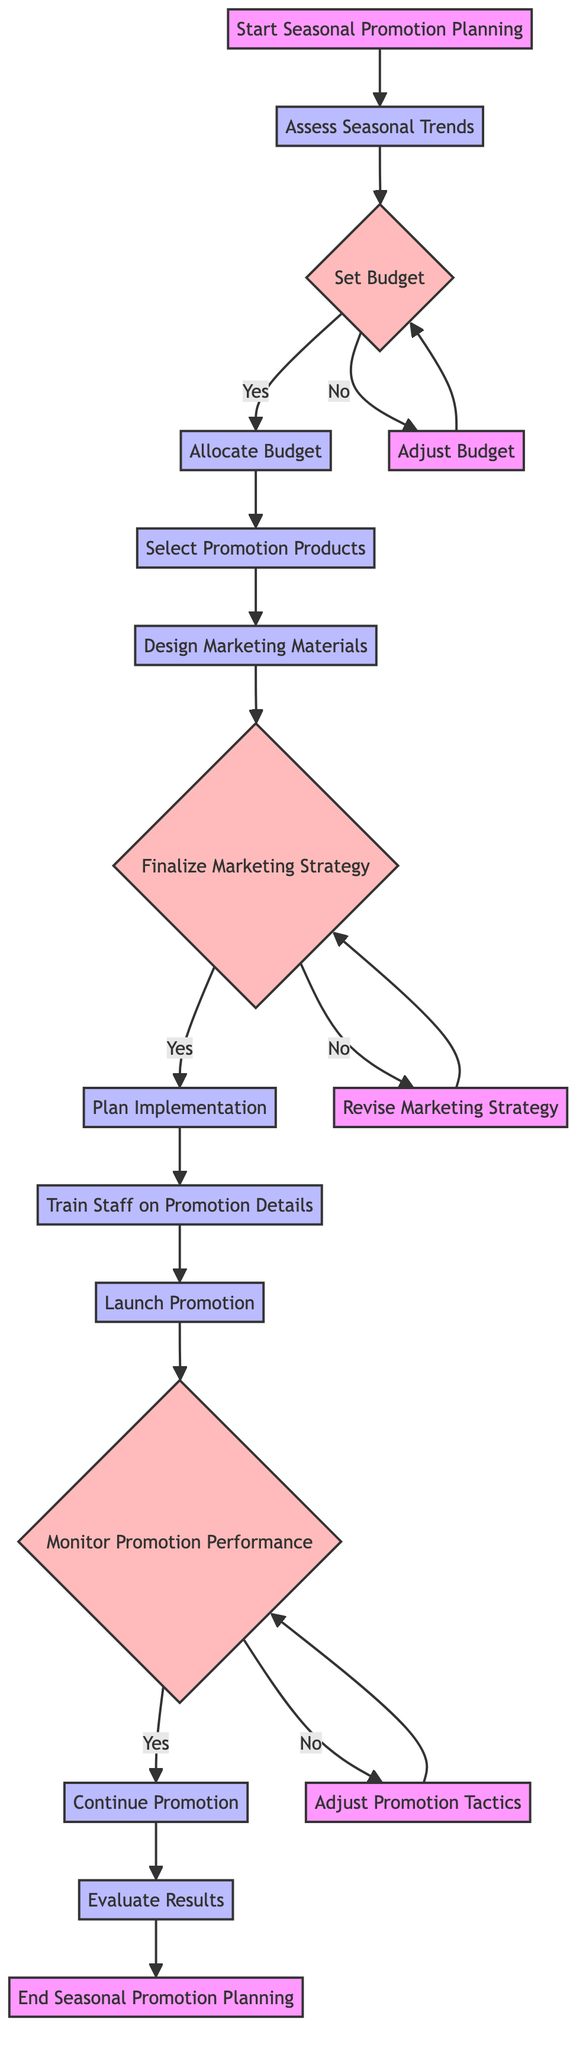What is the first step in the process? The diagram starts with the node labeled "Start Seasonal Promotion Planning", indicating that this is the initial step in the flowchart.
Answer: Start Seasonal Promotion Planning How many decision nodes are present in this diagram? The diagram contains three decision nodes: "Set Budget", "Finalize Marketing Strategy", and "Monitor Promotion Performance". Counting these gives a total of three.
Answer: 3 What happens if the marketing budget is not sufficient? If the marketing budget is not sufficient, the flow proceeds to the "Adjust Budget" process, indicating that adjustments will be made to the budget.
Answer: Adjust Budget What are the final two steps in the promotion planning process? The last two steps in the flowchart are "Evaluate Results" followed by "End Seasonal Promotion Planning", showing the conclusion of the process after evaluation.
Answer: Evaluate Results, End Seasonal Promotion Planning What does the node "Train Staff on Promotion Details" lead to? The "Train Staff on Promotion Details" process directly leads to the "Launch Promotion" process, indicating the sequence of events from training to launching.
Answer: Launch Promotion If the marketing strategy is not approved, what is the next action? If the marketing strategy is not approved, the next action is to "Revise Marketing Strategy", indicating further modifications will be made.
Answer: Revise Marketing Strategy What occurs after launching the promotion? After launching the promotion, the diagram moves to the decision node "Monitor Promotion Performance", indicating that the effectiveness of the promotion will be evaluated next.
Answer: Monitor Promotion Performance What is the outcome if the promotion is successful? If the promotion is deemed successful, the next step is to "Continue Promotion", thereby maintaining the current promotional efforts.
Answer: Continue Promotion What processes follow the "Design Marketing Materials" node? The processes that follow "Design Marketing Materials" are "Finalize Marketing Strategy", indicating that marketing materials are completed before finalizing the strategy.
Answer: Finalize Marketing Strategy 